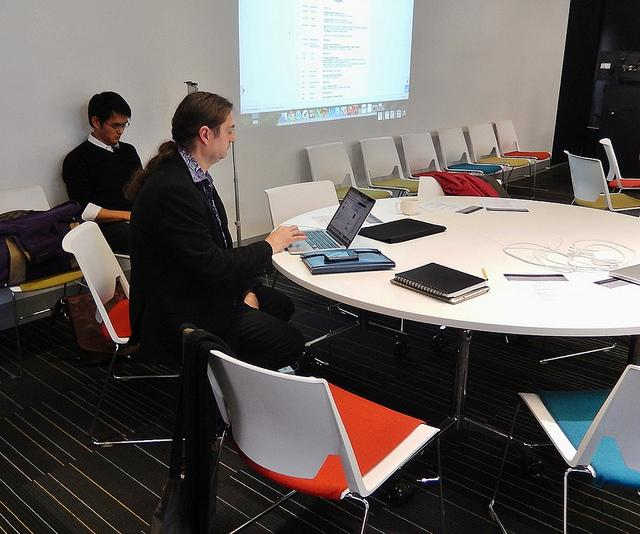What is the operating system being projected? mac os 